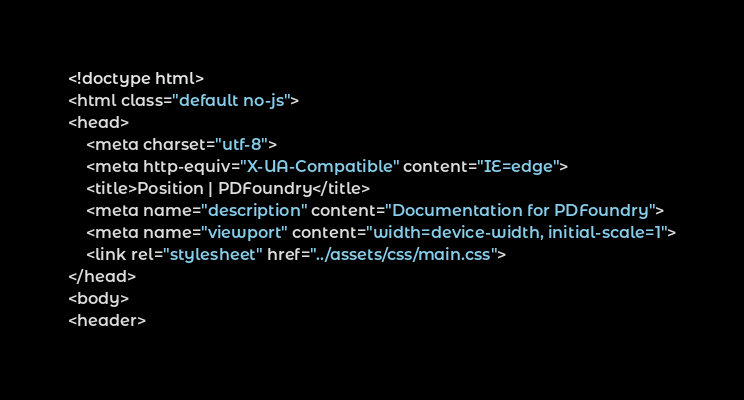<code> <loc_0><loc_0><loc_500><loc_500><_HTML_><!doctype html>
<html class="default no-js">
<head>
	<meta charset="utf-8">
	<meta http-equiv="X-UA-Compatible" content="IE=edge">
	<title>Position | PDFoundry</title>
	<meta name="description" content="Documentation for PDFoundry">
	<meta name="viewport" content="width=device-width, initial-scale=1">
	<link rel="stylesheet" href="../assets/css/main.css">
</head>
<body>
<header></code> 